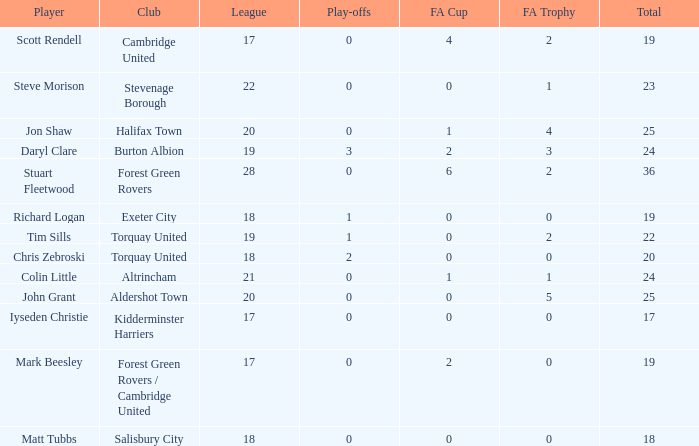Which mean total had Tim Sills as a player? 22.0. 